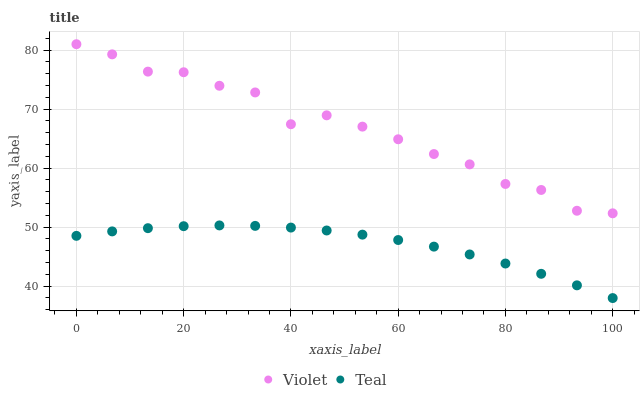Does Teal have the minimum area under the curve?
Answer yes or no. Yes. Does Violet have the maximum area under the curve?
Answer yes or no. Yes. Does Violet have the minimum area under the curve?
Answer yes or no. No. Is Teal the smoothest?
Answer yes or no. Yes. Is Violet the roughest?
Answer yes or no. Yes. Is Violet the smoothest?
Answer yes or no. No. Does Teal have the lowest value?
Answer yes or no. Yes. Does Violet have the lowest value?
Answer yes or no. No. Does Violet have the highest value?
Answer yes or no. Yes. Is Teal less than Violet?
Answer yes or no. Yes. Is Violet greater than Teal?
Answer yes or no. Yes. Does Teal intersect Violet?
Answer yes or no. No. 